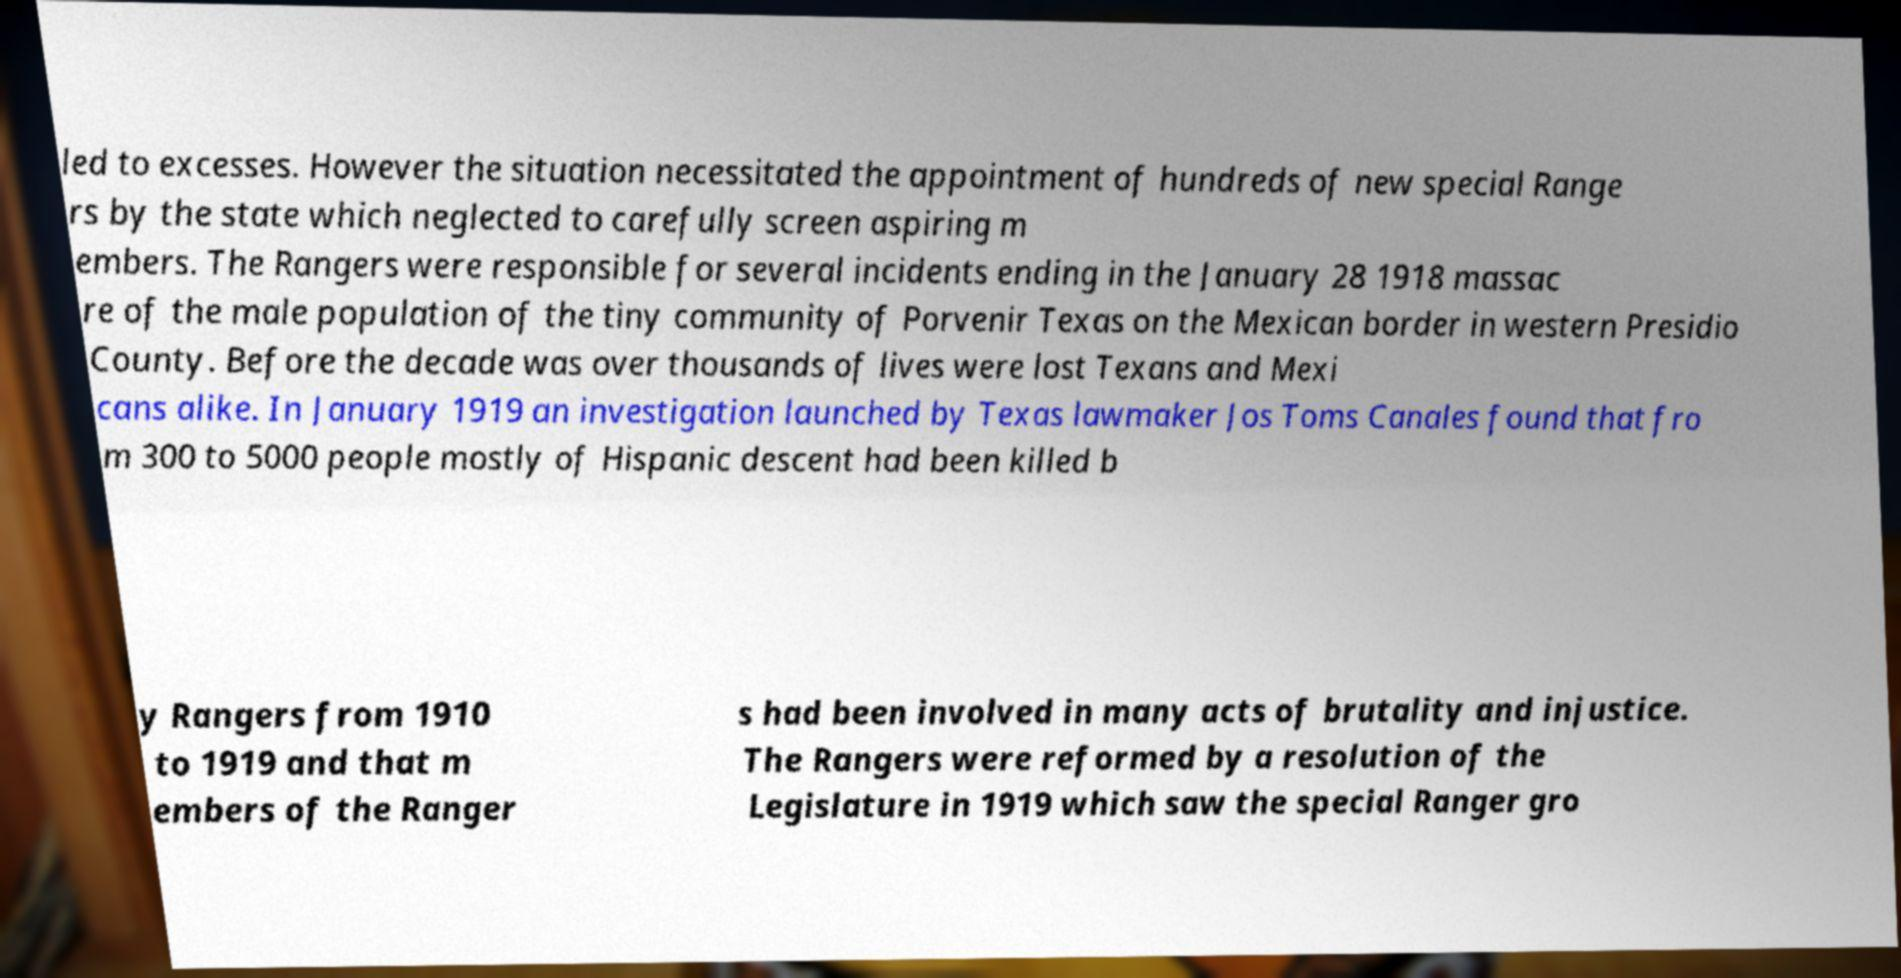Please read and relay the text visible in this image. What does it say? led to excesses. However the situation necessitated the appointment of hundreds of new special Range rs by the state which neglected to carefully screen aspiring m embers. The Rangers were responsible for several incidents ending in the January 28 1918 massac re of the male population of the tiny community of Porvenir Texas on the Mexican border in western Presidio County. Before the decade was over thousands of lives were lost Texans and Mexi cans alike. In January 1919 an investigation launched by Texas lawmaker Jos Toms Canales found that fro m 300 to 5000 people mostly of Hispanic descent had been killed b y Rangers from 1910 to 1919 and that m embers of the Ranger s had been involved in many acts of brutality and injustice. The Rangers were reformed by a resolution of the Legislature in 1919 which saw the special Ranger gro 